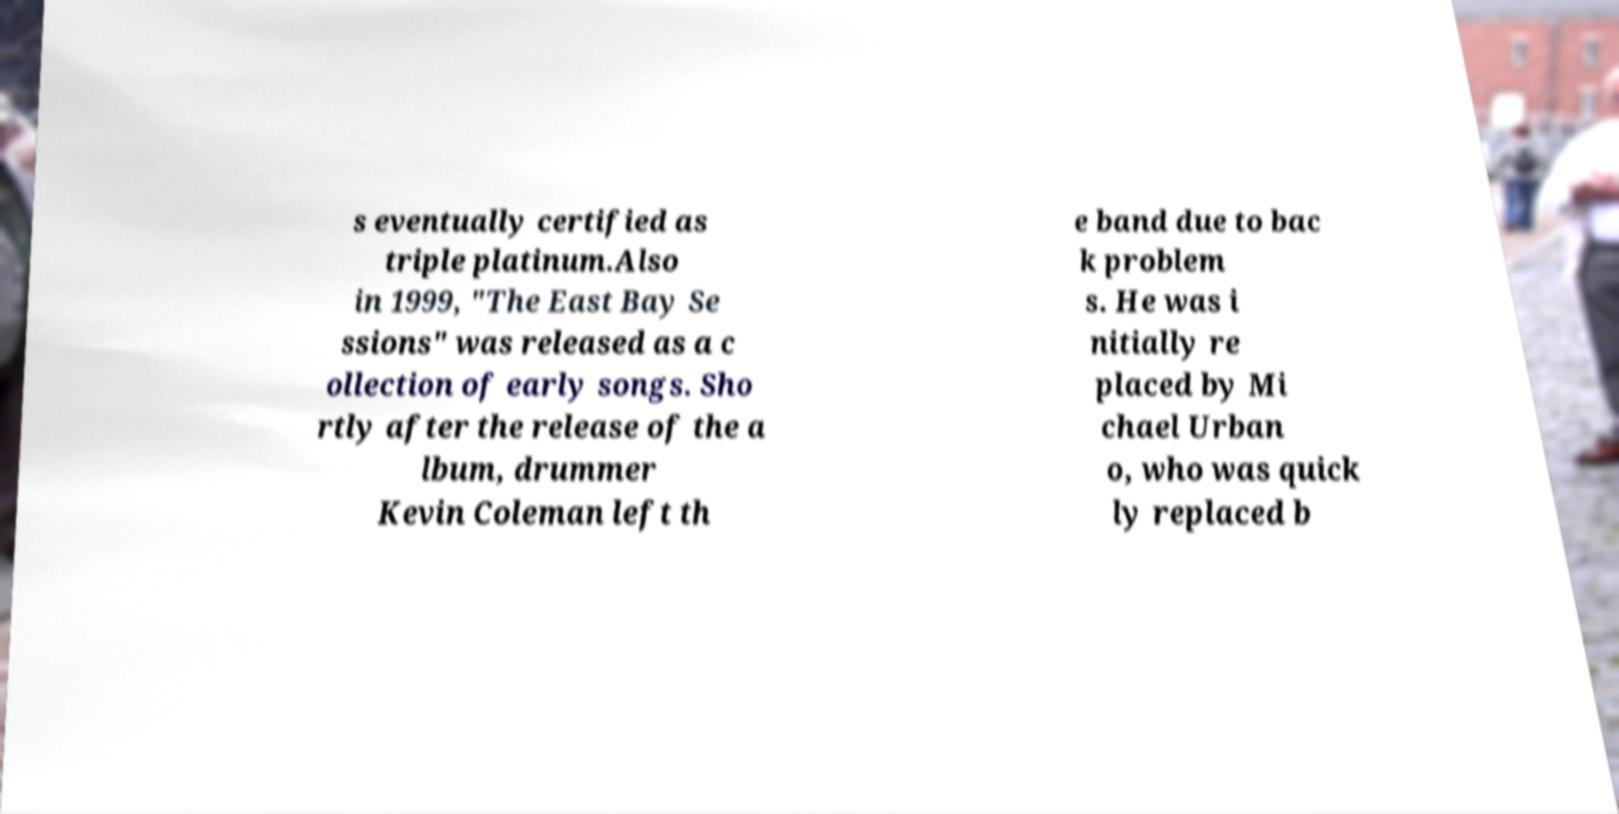Can you accurately transcribe the text from the provided image for me? s eventually certified as triple platinum.Also in 1999, "The East Bay Se ssions" was released as a c ollection of early songs. Sho rtly after the release of the a lbum, drummer Kevin Coleman left th e band due to bac k problem s. He was i nitially re placed by Mi chael Urban o, who was quick ly replaced b 